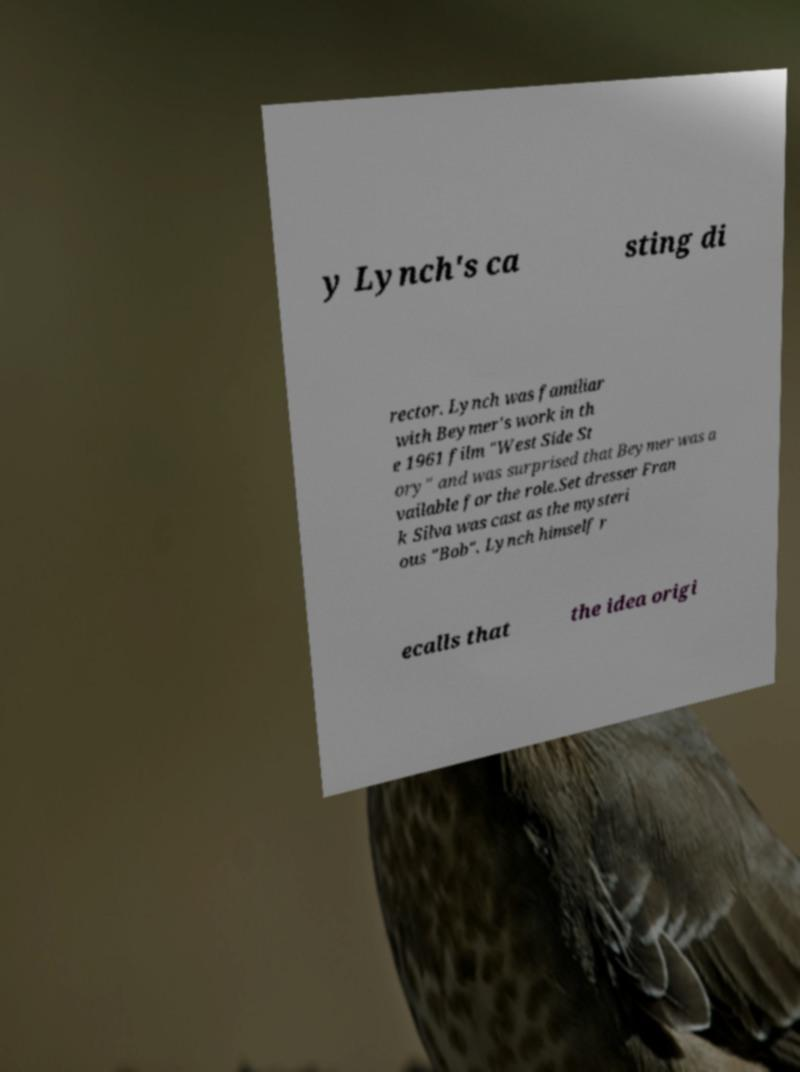Could you extract and type out the text from this image? y Lynch's ca sting di rector. Lynch was familiar with Beymer's work in th e 1961 film "West Side St ory" and was surprised that Beymer was a vailable for the role.Set dresser Fran k Silva was cast as the mysteri ous "Bob". Lynch himself r ecalls that the idea origi 